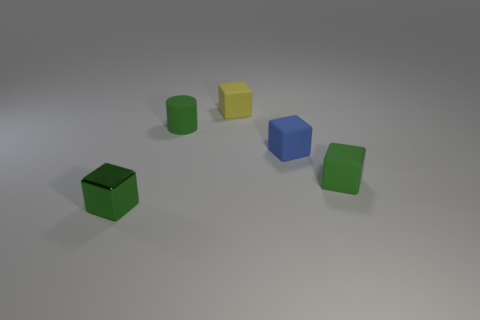Subtract all tiny blue rubber cubes. How many cubes are left? 3 Subtract 1 blocks. How many blocks are left? 3 Add 3 yellow matte things. How many objects exist? 8 Subtract all purple cubes. Subtract all brown balls. How many cubes are left? 4 Subtract 0 brown blocks. How many objects are left? 5 Subtract all cylinders. How many objects are left? 4 Subtract all yellow blocks. Subtract all tiny rubber blocks. How many objects are left? 1 Add 4 metal cubes. How many metal cubes are left? 5 Add 4 big gray cubes. How many big gray cubes exist? 4 